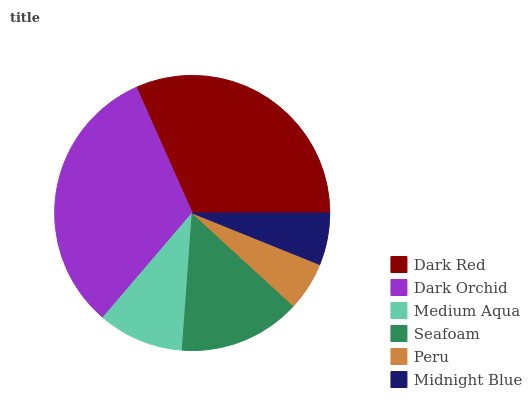Is Peru the minimum?
Answer yes or no. Yes. Is Dark Orchid the maximum?
Answer yes or no. Yes. Is Medium Aqua the minimum?
Answer yes or no. No. Is Medium Aqua the maximum?
Answer yes or no. No. Is Dark Orchid greater than Medium Aqua?
Answer yes or no. Yes. Is Medium Aqua less than Dark Orchid?
Answer yes or no. Yes. Is Medium Aqua greater than Dark Orchid?
Answer yes or no. No. Is Dark Orchid less than Medium Aqua?
Answer yes or no. No. Is Seafoam the high median?
Answer yes or no. Yes. Is Medium Aqua the low median?
Answer yes or no. Yes. Is Dark Orchid the high median?
Answer yes or no. No. Is Seafoam the low median?
Answer yes or no. No. 